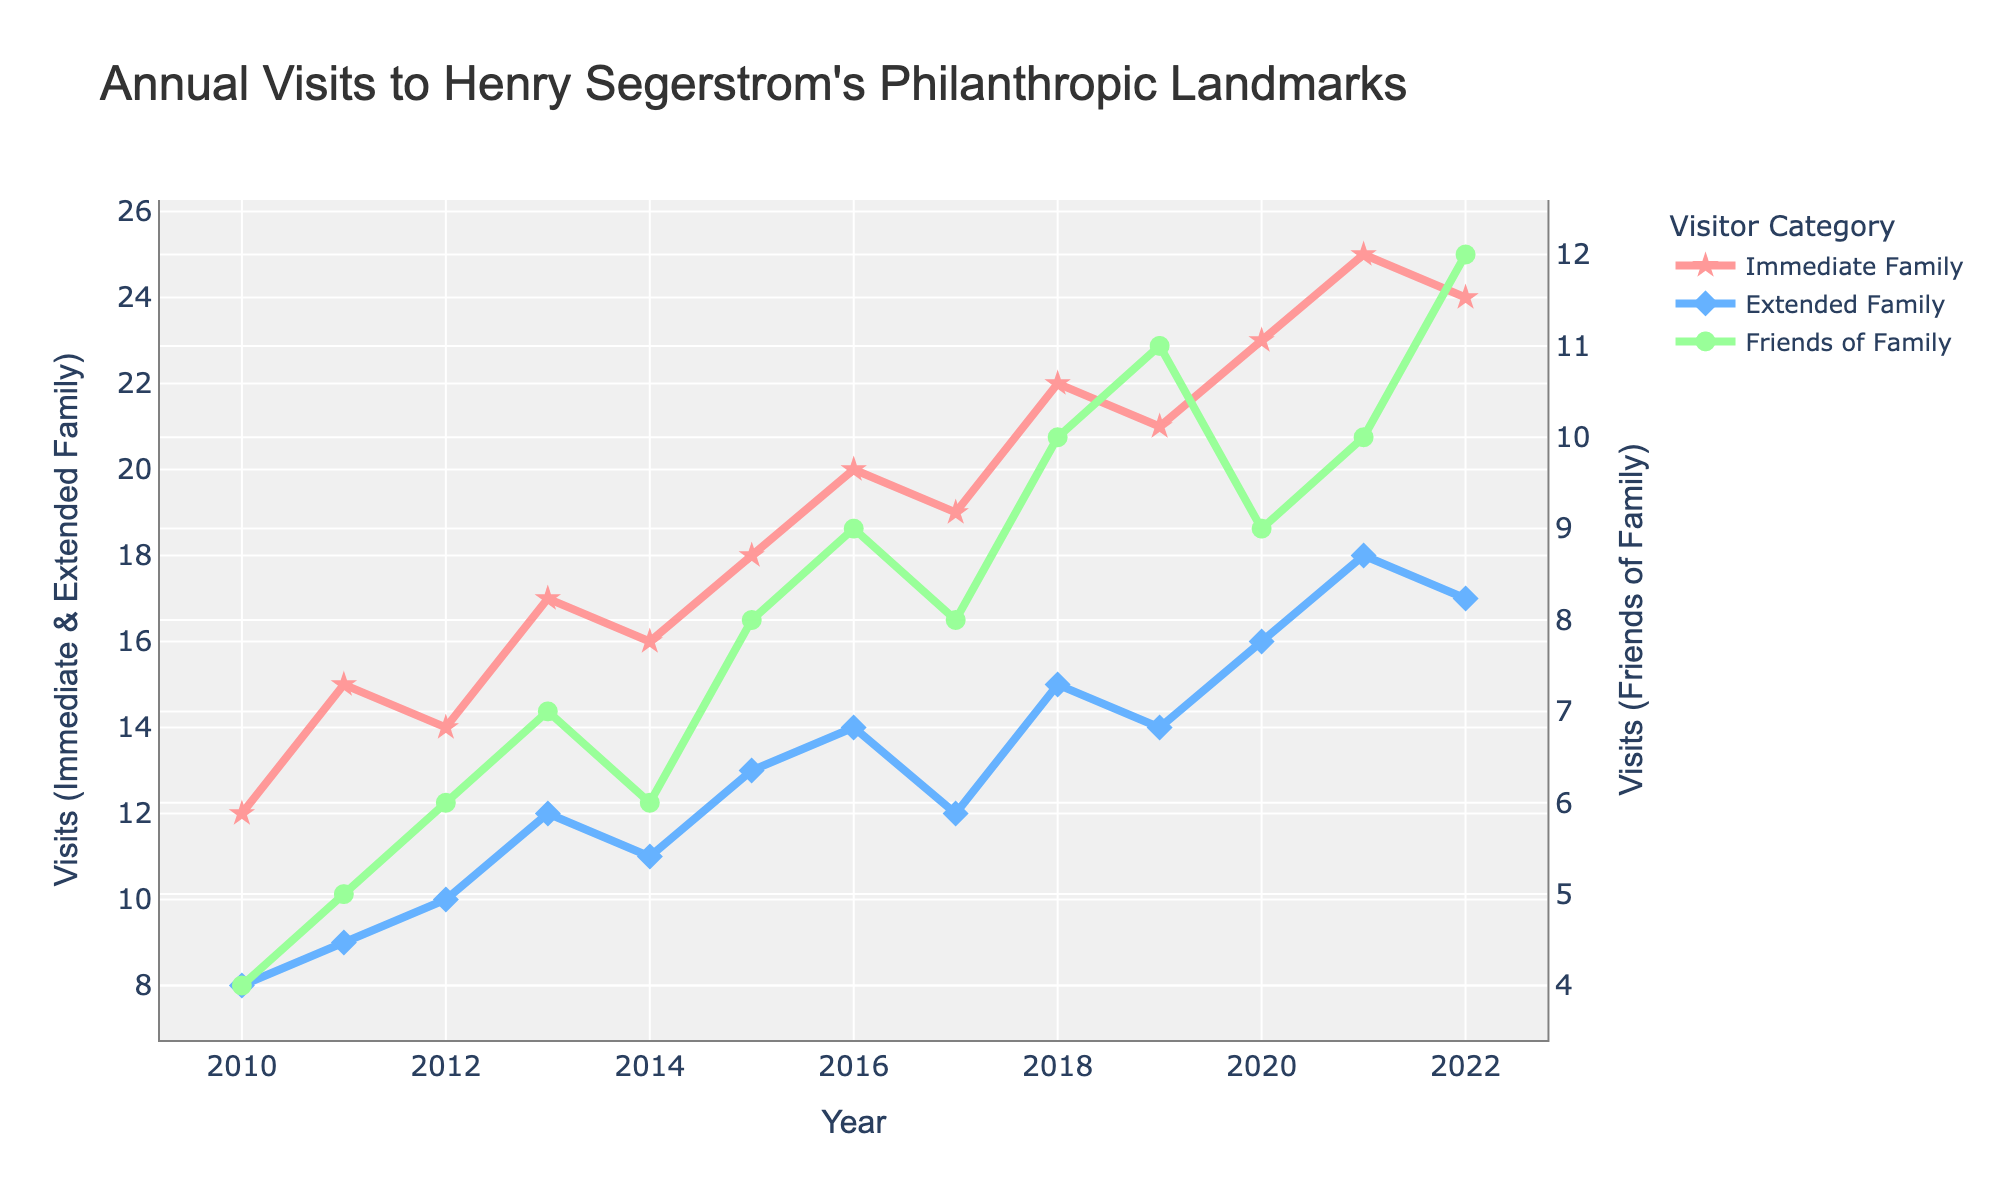What's the title of the figure? The title is usually found at the top of the figure, summarizing its content. In this case, it explicitly states the main subject of the plot.
Answer: Annual Visits to Henry Segerstrom's Philanthropic Landmarks Which year had the highest number of visits by Immediate Family? Look for the peak point on the Immediate Family line (red line with star markers) on the x-axis. The highest peak is at 2021.
Answer: 2021 How many visits did the Extended Family make in 2018? Locate the year 2018 on the x-axis and then see at what point the blue line (diamond markers) intersects it. The number corresponding to the y-axis is 15.
Answer: 15 What's the difference in the number of visits between Immediate Family and Friends of Family in 2020? Locate 2020 on the x-axis. Immediate Family visits are 23, and Friends of Family visits are 9. Subtracting 9 from 23 gives you the difference.
Answer: 14 Which category saw an increase every year from 2010 to 2013? Check each category's line from 2010 to 2013. Only the lines for Immediate Family and Extended Family have points lying higher each subsequent year. Any declining or constant part disqualifies the series.
Answer: Immediate Family What is the average number of visits by Friends of Family from 2012 to 2022? Sum the visits made by Friends of Family from 2012 to 2022 and divide by the number of years (11). The sum is 6+7+6+8+9+8+10+11+9+10+12 = 96. Average = 96/11.
Answer: 8.73 Which year did Extended Family visits and Friends of Family visits have the same value? Trace the data points for both categories. Both lines (blue and green) intersect at the same y-value in 2010, which happens at y = 8.
Answer: None Did the immediate family visit more than 18 times in years before 2015? Scan the graph before 2015 for Immediate Family visits. All counts remain below 18 before 2015.
Answer: No Compare the trends of Immediate Family and Extended Family visits from 2016 to 2018. Observe the corresponding segments of both lines. Both categories' visits increase, but Immediate Family's growth is steeper.
Answer: Both increased What is the overall trend in visits by the Immediate Family from 2010 to 2022? Follow the line's trajectory from start to end. The overall direction from left (2010) to right (2022) shows a clear upward trend.
Answer: Increasing 